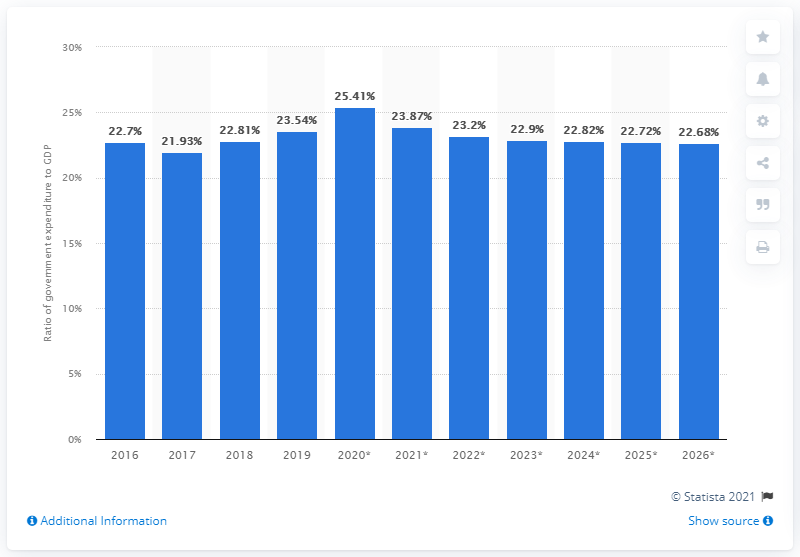Identify some key points in this picture. According to the Department of Statistics Malaysia, in 2019, government expenditure accounted for 23.54% of Malaysia's gross domestic product. 